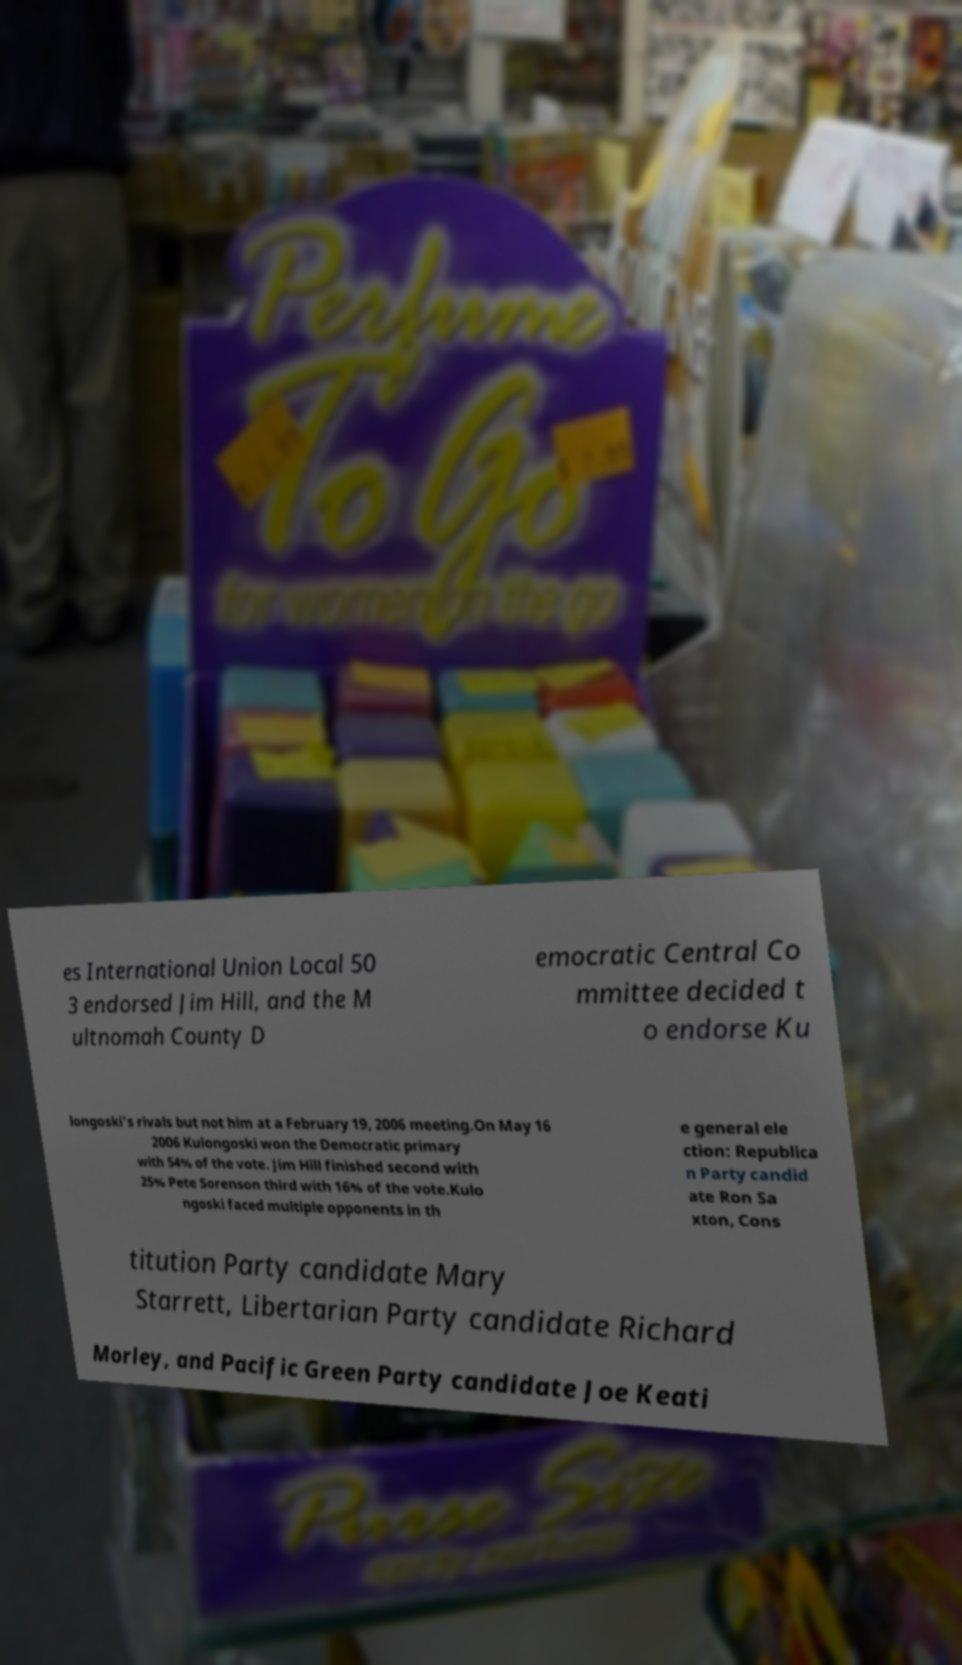What messages or text are displayed in this image? I need them in a readable, typed format. es International Union Local 50 3 endorsed Jim Hill, and the M ultnomah County D emocratic Central Co mmittee decided t o endorse Ku longoski's rivals but not him at a February 19, 2006 meeting.On May 16 2006 Kulongoski won the Democratic primary with 54% of the vote. Jim Hill finished second with 25% Pete Sorenson third with 16% of the vote.Kulo ngoski faced multiple opponents in th e general ele ction: Republica n Party candid ate Ron Sa xton, Cons titution Party candidate Mary Starrett, Libertarian Party candidate Richard Morley, and Pacific Green Party candidate Joe Keati 